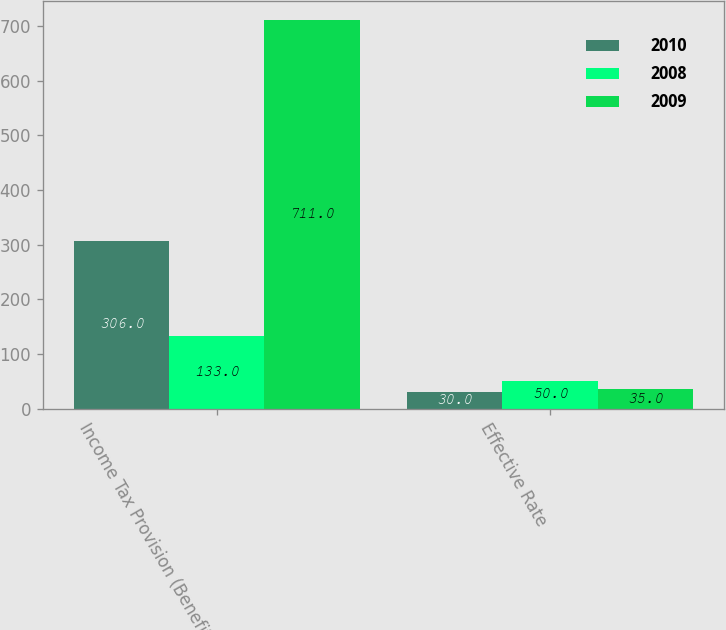Convert chart. <chart><loc_0><loc_0><loc_500><loc_500><stacked_bar_chart><ecel><fcel>Income Tax Provision (Benefit)<fcel>Effective Rate<nl><fcel>2010<fcel>306<fcel>30<nl><fcel>2008<fcel>133<fcel>50<nl><fcel>2009<fcel>711<fcel>35<nl></chart> 